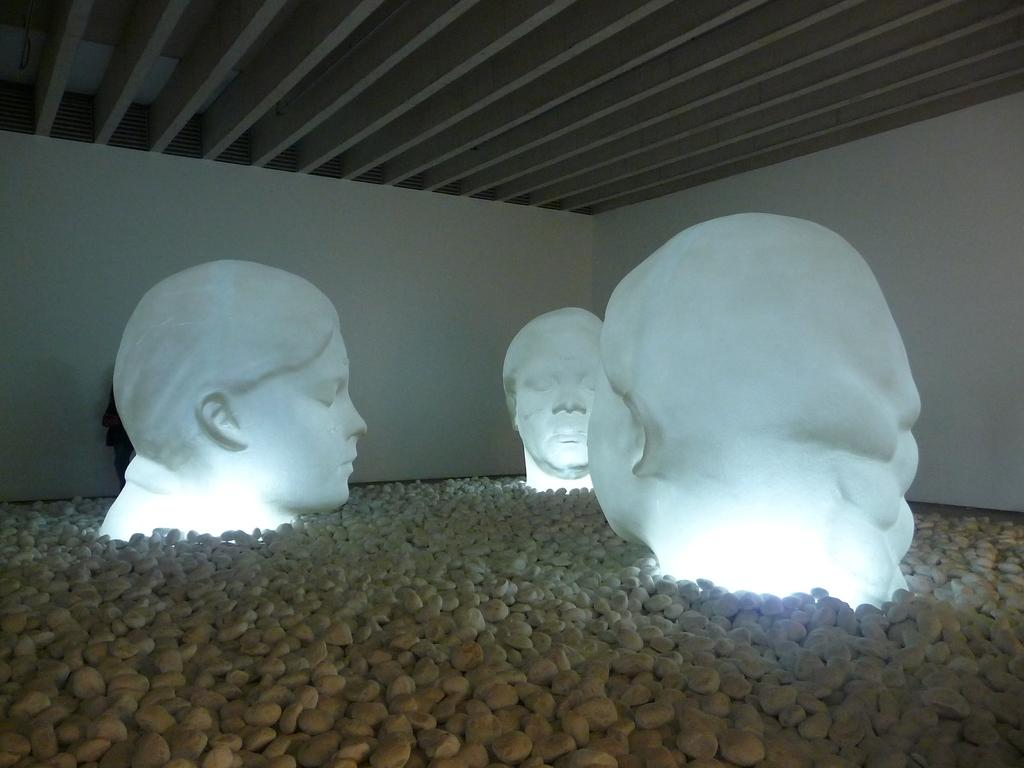What type of sculptures can be seen in the image? There are sculptures of heads on stones in the image. What part of a building or structure is visible at the top of the image? There is a ceiling visible at the top of the image. What type of regret can be seen on the faces of the sculptures in the image? There is no indication of regret on the faces of the sculptures in the image, as they are made of stone and do not have facial expressions. 